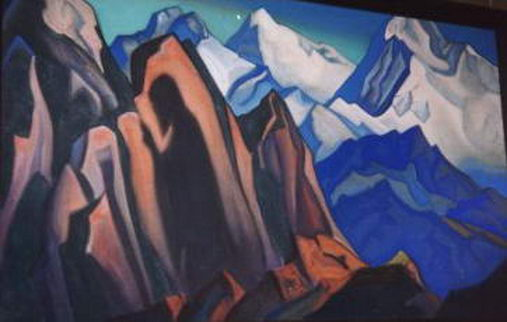Can you help me visualize how this landscape would look in different seasons? Certainly! In spring, the landscape would be adorned with blooming wildflowers, adding splashes of pink, yellow, and green to the already vibrant colors of the mountains. The fresh, crisp air would enhance the clarity of the geometric shapes, making the scene feel rejuvenated and alive. In summer, the warmer hues of the rocks would intensify under the bright sun, casting sharp shadows and adding a sense of boldness to the mountains. The sky might be a vivid azure, offering a stark contrast to the earthy tones of the landscape. In autumn, the cubist depiction would take on rich oranges, reds, and golden browns, as the foliage changed color. This would create a warm, nostalgic ambiance, with the geometric shapes resembling the patchwork of fallen leaves. Finally, in winter, the mountains would be blanketed in soft, white snow, muting the vibrant palette and transforming the scene into a serene, almost monochromatic vision. The crisp blues and greys would dominate, and the angular lines of the cubist style would evoke a peaceful, hushed stillness. 